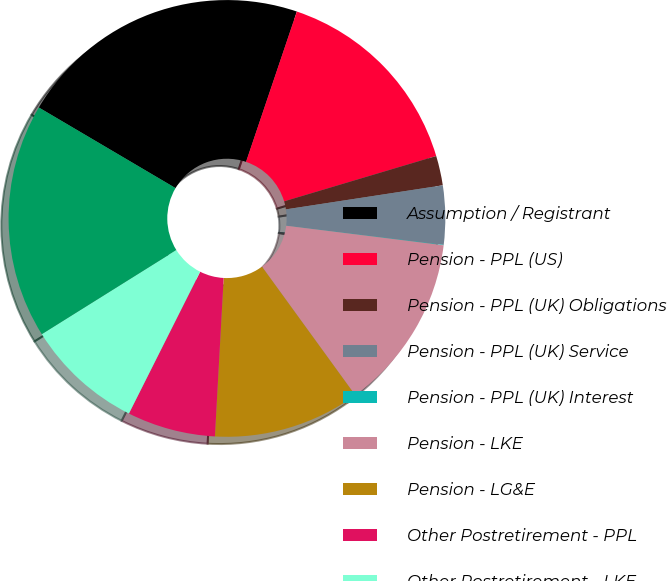Convert chart to OTSL. <chart><loc_0><loc_0><loc_500><loc_500><pie_chart><fcel>Assumption / Registrant<fcel>Pension - PPL (US)<fcel>Pension - PPL (UK) Obligations<fcel>Pension - PPL (UK) Service<fcel>Pension - PPL (UK) Interest<fcel>Pension - LKE<fcel>Pension - LG&E<fcel>Other Postretirement - PPL<fcel>Other Postretirement - LKE<fcel>Pension - PPL (UK)<nl><fcel>21.71%<fcel>15.2%<fcel>2.19%<fcel>4.36%<fcel>0.03%<fcel>13.04%<fcel>10.87%<fcel>6.53%<fcel>8.7%<fcel>17.37%<nl></chart> 